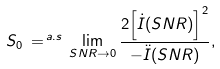Convert formula to latex. <formula><loc_0><loc_0><loc_500><loc_500>S _ { 0 } \, = ^ { \, a . s } \, \lim _ { S N R \rightarrow 0 } \frac { 2 { \left [ \dot { I } ( S N R ) \right ] } ^ { 2 } } { - \ddot { I } ( S N R ) } ,</formula> 